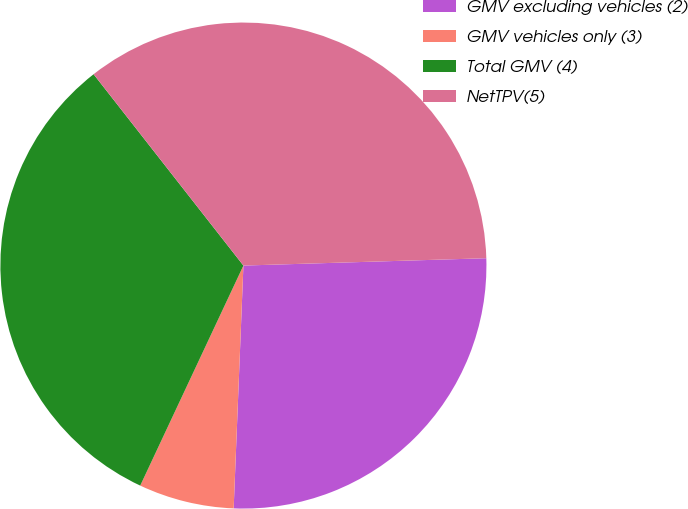Convert chart. <chart><loc_0><loc_0><loc_500><loc_500><pie_chart><fcel>GMV excluding vehicles (2)<fcel>GMV vehicles only (3)<fcel>Total GMV (4)<fcel>NetTPV(5)<nl><fcel>26.12%<fcel>6.34%<fcel>32.45%<fcel>35.09%<nl></chart> 